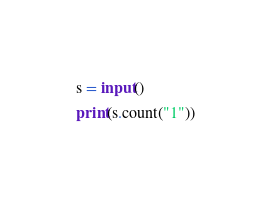Convert code to text. <code><loc_0><loc_0><loc_500><loc_500><_Python_>s = input()
print(s.count("1"))</code> 